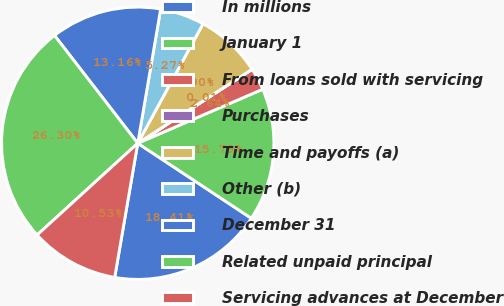<chart> <loc_0><loc_0><loc_500><loc_500><pie_chart><fcel>In millions<fcel>January 1<fcel>From loans sold with servicing<fcel>Purchases<fcel>Time and payoffs (a)<fcel>Other (b)<fcel>December 31<fcel>Related unpaid principal<fcel>Servicing advances at December<nl><fcel>18.42%<fcel>15.79%<fcel>2.64%<fcel>0.01%<fcel>7.9%<fcel>5.27%<fcel>13.16%<fcel>26.31%<fcel>10.53%<nl></chart> 